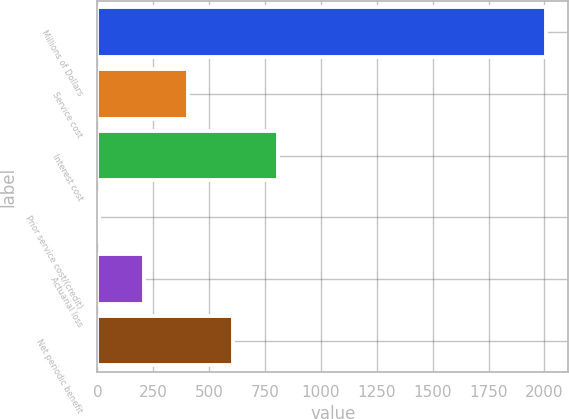<chart> <loc_0><loc_0><loc_500><loc_500><bar_chart><fcel>Millions of Dollars<fcel>Service cost<fcel>Interest cost<fcel>Prior service cost/(credit)<fcel>Actuarial loss<fcel>Net periodic benefit<nl><fcel>2006<fcel>406.8<fcel>806.6<fcel>7<fcel>206.9<fcel>606.7<nl></chart> 